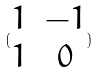Convert formula to latex. <formula><loc_0><loc_0><loc_500><loc_500>( \begin{matrix} 1 & - 1 \\ 1 & 0 \end{matrix} )</formula> 